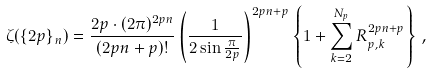<formula> <loc_0><loc_0><loc_500><loc_500>\zeta ( \{ 2 p \} _ { n } ) = \frac { 2 p \cdot ( 2 \pi ) ^ { 2 p n } } { ( 2 p n + p ) ! } \left ( \frac { 1 } { 2 \sin \frac { \pi } { 2 p } } \right ) ^ { 2 p n + p } \left \{ 1 + \sum _ { k = 2 } ^ { N _ { p } } R _ { p , k } ^ { 2 p n + p } \right \} \, ,</formula> 